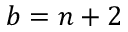Convert formula to latex. <formula><loc_0><loc_0><loc_500><loc_500>b = n + 2</formula> 